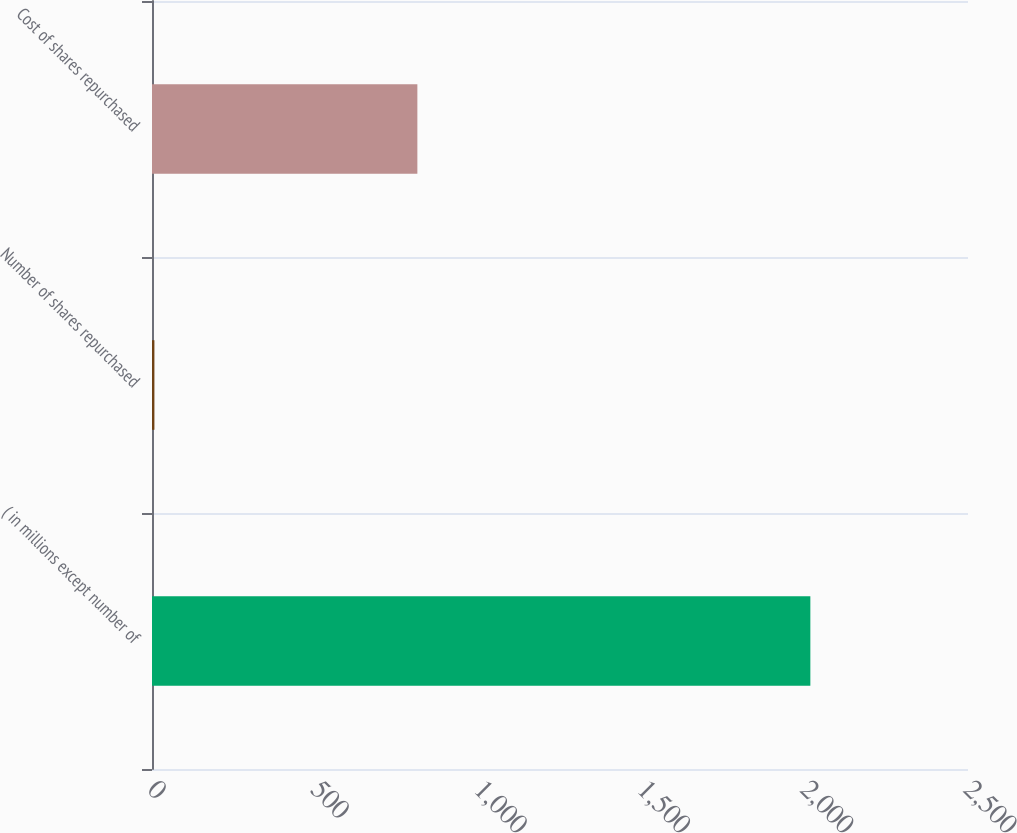Convert chart. <chart><loc_0><loc_0><loc_500><loc_500><bar_chart><fcel>( in millions except number of<fcel>Number of shares repurchased<fcel>Cost of shares repurchased<nl><fcel>2017<fcel>7.4<fcel>813<nl></chart> 